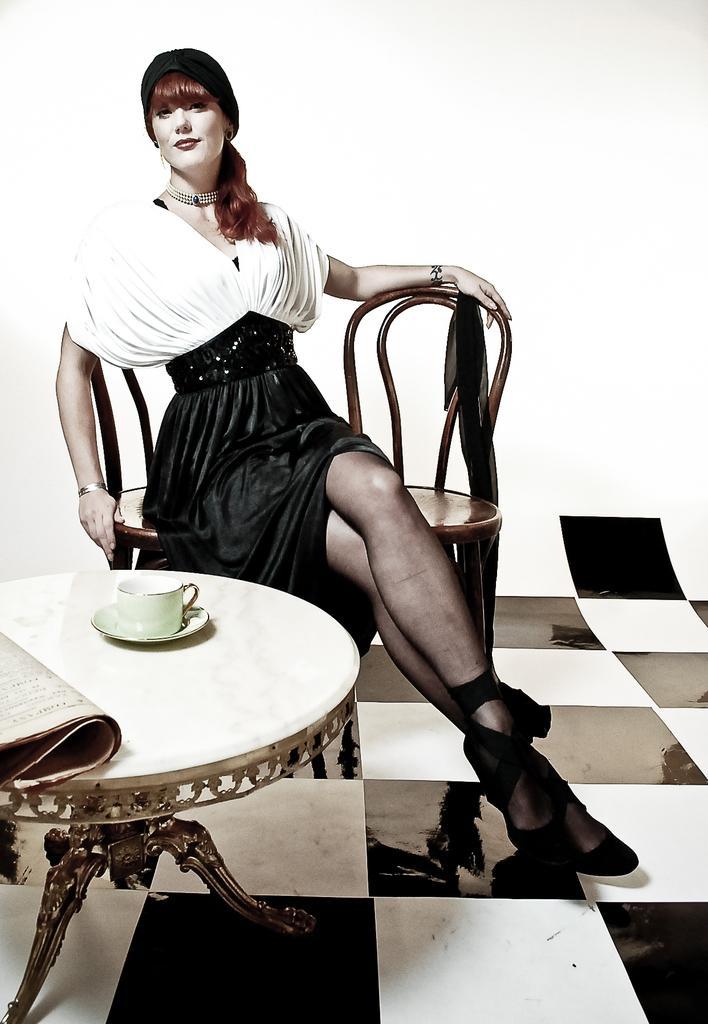Could you give a brief overview of what you see in this image? there is a floor and the woman is sitting on the chair the cup and soccer is placing on the table and woman is wearing the black skirt and white shirt and she is staring and she is wearing the necklace and she is wearing the shoes. 